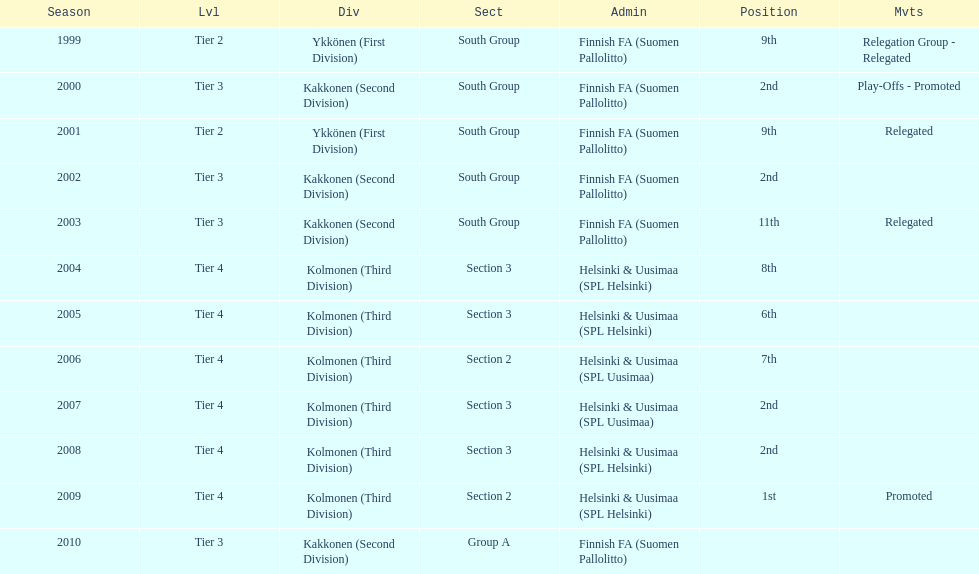How many times were they in tier 3? 4. 